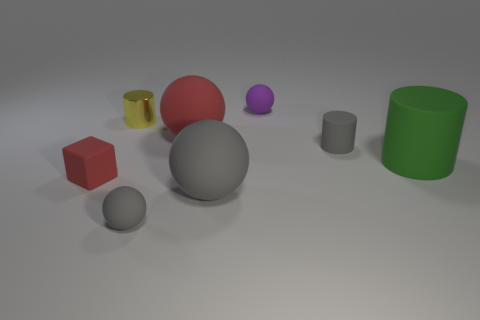Are there an equal number of big rubber balls that are behind the small block and purple balls?
Your answer should be compact. Yes. Is there anything else that is the same material as the tiny yellow thing?
Your answer should be very brief. No. How many small objects are gray rubber objects or cylinders?
Give a very brief answer. 3. What shape is the big matte thing that is the same color as the small cube?
Keep it short and to the point. Sphere. Does the small gray thing that is in front of the gray matte cylinder have the same material as the tiny yellow object?
Keep it short and to the point. No. What is the cylinder that is left of the small gray matte object on the left side of the purple sphere made of?
Make the answer very short. Metal. How many other big things are the same shape as the yellow metallic thing?
Ensure brevity in your answer.  1. There is a gray rubber cylinder that is behind the red object in front of the cylinder on the right side of the tiny gray rubber cylinder; what is its size?
Your response must be concise. Small. How many green objects are either small matte cubes or large rubber objects?
Your answer should be very brief. 1. There is a small gray rubber object that is behind the big gray sphere; does it have the same shape as the large green thing?
Keep it short and to the point. Yes. 